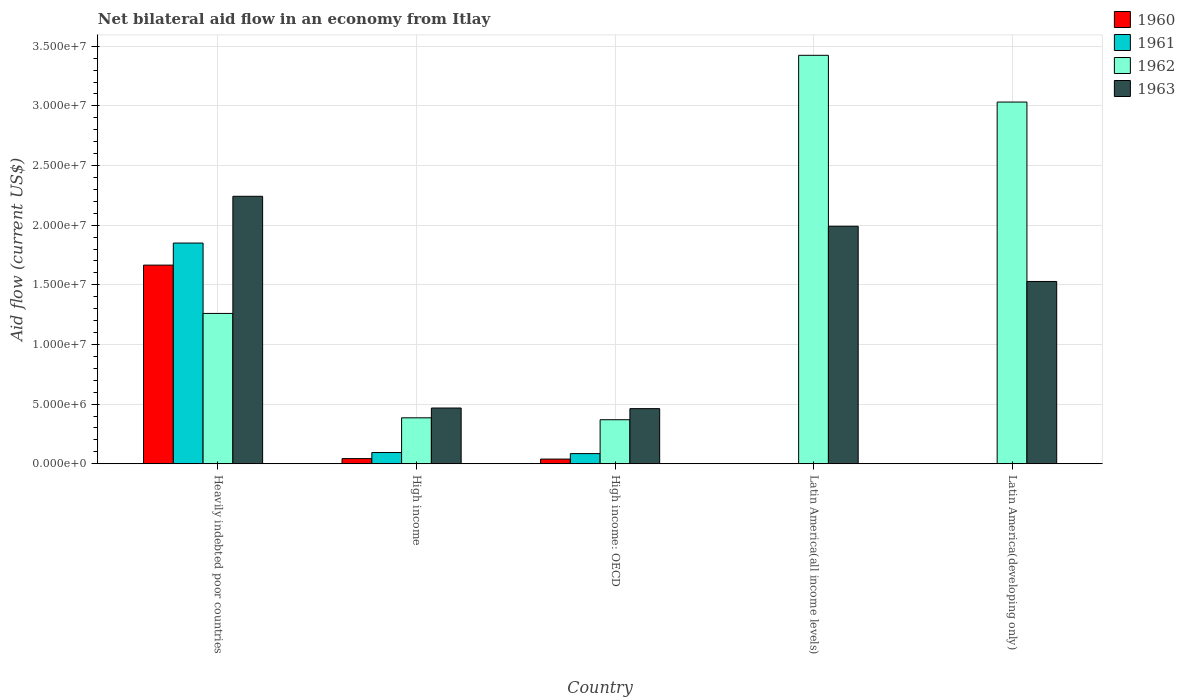How many different coloured bars are there?
Keep it short and to the point. 4. Are the number of bars per tick equal to the number of legend labels?
Provide a short and direct response. No. What is the label of the 4th group of bars from the left?
Ensure brevity in your answer.  Latin America(all income levels). In how many cases, is the number of bars for a given country not equal to the number of legend labels?
Offer a terse response. 2. What is the net bilateral aid flow in 1962 in Latin America(developing only)?
Give a very brief answer. 3.03e+07. Across all countries, what is the maximum net bilateral aid flow in 1960?
Your response must be concise. 1.66e+07. Across all countries, what is the minimum net bilateral aid flow in 1962?
Give a very brief answer. 3.69e+06. In which country was the net bilateral aid flow in 1960 maximum?
Your answer should be very brief. Heavily indebted poor countries. What is the total net bilateral aid flow in 1963 in the graph?
Provide a succinct answer. 6.69e+07. What is the difference between the net bilateral aid flow in 1962 in High income and that in Latin America(all income levels)?
Offer a very short reply. -3.04e+07. What is the difference between the net bilateral aid flow in 1962 in Heavily indebted poor countries and the net bilateral aid flow in 1963 in High income: OECD?
Your answer should be very brief. 7.98e+06. What is the average net bilateral aid flow in 1962 per country?
Your response must be concise. 1.69e+07. What is the difference between the net bilateral aid flow of/in 1962 and net bilateral aid flow of/in 1963 in Heavily indebted poor countries?
Provide a short and direct response. -9.82e+06. In how many countries, is the net bilateral aid flow in 1962 greater than 12000000 US$?
Your response must be concise. 3. What is the ratio of the net bilateral aid flow in 1963 in High income to that in Latin America(all income levels)?
Give a very brief answer. 0.23. Is the net bilateral aid flow in 1961 in High income less than that in High income: OECD?
Your answer should be compact. No. What is the difference between the highest and the second highest net bilateral aid flow in 1960?
Your answer should be compact. 1.63e+07. What is the difference between the highest and the lowest net bilateral aid flow in 1963?
Provide a short and direct response. 1.78e+07. Is it the case that in every country, the sum of the net bilateral aid flow in 1960 and net bilateral aid flow in 1961 is greater than the net bilateral aid flow in 1963?
Offer a terse response. No. How many bars are there?
Give a very brief answer. 16. Are all the bars in the graph horizontal?
Give a very brief answer. No. How many countries are there in the graph?
Ensure brevity in your answer.  5. Are the values on the major ticks of Y-axis written in scientific E-notation?
Give a very brief answer. Yes. Does the graph contain any zero values?
Provide a short and direct response. Yes. How many legend labels are there?
Give a very brief answer. 4. What is the title of the graph?
Give a very brief answer. Net bilateral aid flow in an economy from Itlay. Does "1966" appear as one of the legend labels in the graph?
Your answer should be very brief. No. What is the label or title of the X-axis?
Give a very brief answer. Country. What is the label or title of the Y-axis?
Provide a succinct answer. Aid flow (current US$). What is the Aid flow (current US$) in 1960 in Heavily indebted poor countries?
Offer a terse response. 1.66e+07. What is the Aid flow (current US$) in 1961 in Heavily indebted poor countries?
Your answer should be compact. 1.85e+07. What is the Aid flow (current US$) in 1962 in Heavily indebted poor countries?
Ensure brevity in your answer.  1.26e+07. What is the Aid flow (current US$) of 1963 in Heavily indebted poor countries?
Ensure brevity in your answer.  2.24e+07. What is the Aid flow (current US$) of 1960 in High income?
Provide a succinct answer. 4.30e+05. What is the Aid flow (current US$) of 1961 in High income?
Make the answer very short. 9.40e+05. What is the Aid flow (current US$) of 1962 in High income?
Your response must be concise. 3.85e+06. What is the Aid flow (current US$) of 1963 in High income?
Offer a terse response. 4.67e+06. What is the Aid flow (current US$) in 1961 in High income: OECD?
Provide a succinct answer. 8.50e+05. What is the Aid flow (current US$) in 1962 in High income: OECD?
Keep it short and to the point. 3.69e+06. What is the Aid flow (current US$) of 1963 in High income: OECD?
Give a very brief answer. 4.62e+06. What is the Aid flow (current US$) of 1961 in Latin America(all income levels)?
Offer a very short reply. 0. What is the Aid flow (current US$) in 1962 in Latin America(all income levels)?
Give a very brief answer. 3.42e+07. What is the Aid flow (current US$) in 1963 in Latin America(all income levels)?
Keep it short and to the point. 1.99e+07. What is the Aid flow (current US$) of 1961 in Latin America(developing only)?
Give a very brief answer. 0. What is the Aid flow (current US$) in 1962 in Latin America(developing only)?
Offer a terse response. 3.03e+07. What is the Aid flow (current US$) of 1963 in Latin America(developing only)?
Offer a very short reply. 1.53e+07. Across all countries, what is the maximum Aid flow (current US$) of 1960?
Make the answer very short. 1.66e+07. Across all countries, what is the maximum Aid flow (current US$) of 1961?
Keep it short and to the point. 1.85e+07. Across all countries, what is the maximum Aid flow (current US$) of 1962?
Your response must be concise. 3.42e+07. Across all countries, what is the maximum Aid flow (current US$) in 1963?
Your response must be concise. 2.24e+07. Across all countries, what is the minimum Aid flow (current US$) of 1960?
Give a very brief answer. 0. Across all countries, what is the minimum Aid flow (current US$) in 1961?
Your response must be concise. 0. Across all countries, what is the minimum Aid flow (current US$) in 1962?
Keep it short and to the point. 3.69e+06. Across all countries, what is the minimum Aid flow (current US$) of 1963?
Give a very brief answer. 4.62e+06. What is the total Aid flow (current US$) in 1960 in the graph?
Give a very brief answer. 1.75e+07. What is the total Aid flow (current US$) in 1961 in the graph?
Your response must be concise. 2.03e+07. What is the total Aid flow (current US$) of 1962 in the graph?
Ensure brevity in your answer.  8.47e+07. What is the total Aid flow (current US$) in 1963 in the graph?
Keep it short and to the point. 6.69e+07. What is the difference between the Aid flow (current US$) in 1960 in Heavily indebted poor countries and that in High income?
Give a very brief answer. 1.62e+07. What is the difference between the Aid flow (current US$) in 1961 in Heavily indebted poor countries and that in High income?
Give a very brief answer. 1.76e+07. What is the difference between the Aid flow (current US$) in 1962 in Heavily indebted poor countries and that in High income?
Make the answer very short. 8.75e+06. What is the difference between the Aid flow (current US$) of 1963 in Heavily indebted poor countries and that in High income?
Make the answer very short. 1.78e+07. What is the difference between the Aid flow (current US$) of 1960 in Heavily indebted poor countries and that in High income: OECD?
Keep it short and to the point. 1.63e+07. What is the difference between the Aid flow (current US$) in 1961 in Heavily indebted poor countries and that in High income: OECD?
Make the answer very short. 1.76e+07. What is the difference between the Aid flow (current US$) of 1962 in Heavily indebted poor countries and that in High income: OECD?
Provide a succinct answer. 8.91e+06. What is the difference between the Aid flow (current US$) in 1963 in Heavily indebted poor countries and that in High income: OECD?
Offer a very short reply. 1.78e+07. What is the difference between the Aid flow (current US$) of 1962 in Heavily indebted poor countries and that in Latin America(all income levels)?
Offer a very short reply. -2.16e+07. What is the difference between the Aid flow (current US$) in 1963 in Heavily indebted poor countries and that in Latin America(all income levels)?
Give a very brief answer. 2.51e+06. What is the difference between the Aid flow (current US$) of 1962 in Heavily indebted poor countries and that in Latin America(developing only)?
Ensure brevity in your answer.  -1.77e+07. What is the difference between the Aid flow (current US$) of 1963 in Heavily indebted poor countries and that in Latin America(developing only)?
Make the answer very short. 7.14e+06. What is the difference between the Aid flow (current US$) in 1962 in High income and that in Latin America(all income levels)?
Your answer should be compact. -3.04e+07. What is the difference between the Aid flow (current US$) of 1963 in High income and that in Latin America(all income levels)?
Provide a short and direct response. -1.52e+07. What is the difference between the Aid flow (current US$) of 1962 in High income and that in Latin America(developing only)?
Your answer should be very brief. -2.65e+07. What is the difference between the Aid flow (current US$) in 1963 in High income and that in Latin America(developing only)?
Provide a short and direct response. -1.06e+07. What is the difference between the Aid flow (current US$) of 1962 in High income: OECD and that in Latin America(all income levels)?
Offer a terse response. -3.06e+07. What is the difference between the Aid flow (current US$) in 1963 in High income: OECD and that in Latin America(all income levels)?
Keep it short and to the point. -1.53e+07. What is the difference between the Aid flow (current US$) of 1962 in High income: OECD and that in Latin America(developing only)?
Keep it short and to the point. -2.66e+07. What is the difference between the Aid flow (current US$) of 1963 in High income: OECD and that in Latin America(developing only)?
Ensure brevity in your answer.  -1.07e+07. What is the difference between the Aid flow (current US$) of 1962 in Latin America(all income levels) and that in Latin America(developing only)?
Make the answer very short. 3.92e+06. What is the difference between the Aid flow (current US$) of 1963 in Latin America(all income levels) and that in Latin America(developing only)?
Ensure brevity in your answer.  4.63e+06. What is the difference between the Aid flow (current US$) in 1960 in Heavily indebted poor countries and the Aid flow (current US$) in 1961 in High income?
Your answer should be compact. 1.57e+07. What is the difference between the Aid flow (current US$) of 1960 in Heavily indebted poor countries and the Aid flow (current US$) of 1962 in High income?
Provide a short and direct response. 1.28e+07. What is the difference between the Aid flow (current US$) of 1960 in Heavily indebted poor countries and the Aid flow (current US$) of 1963 in High income?
Your answer should be compact. 1.20e+07. What is the difference between the Aid flow (current US$) in 1961 in Heavily indebted poor countries and the Aid flow (current US$) in 1962 in High income?
Your answer should be very brief. 1.46e+07. What is the difference between the Aid flow (current US$) in 1961 in Heavily indebted poor countries and the Aid flow (current US$) in 1963 in High income?
Ensure brevity in your answer.  1.38e+07. What is the difference between the Aid flow (current US$) in 1962 in Heavily indebted poor countries and the Aid flow (current US$) in 1963 in High income?
Keep it short and to the point. 7.93e+06. What is the difference between the Aid flow (current US$) in 1960 in Heavily indebted poor countries and the Aid flow (current US$) in 1961 in High income: OECD?
Make the answer very short. 1.58e+07. What is the difference between the Aid flow (current US$) in 1960 in Heavily indebted poor countries and the Aid flow (current US$) in 1962 in High income: OECD?
Offer a very short reply. 1.30e+07. What is the difference between the Aid flow (current US$) of 1960 in Heavily indebted poor countries and the Aid flow (current US$) of 1963 in High income: OECD?
Your answer should be very brief. 1.20e+07. What is the difference between the Aid flow (current US$) of 1961 in Heavily indebted poor countries and the Aid flow (current US$) of 1962 in High income: OECD?
Offer a very short reply. 1.48e+07. What is the difference between the Aid flow (current US$) in 1961 in Heavily indebted poor countries and the Aid flow (current US$) in 1963 in High income: OECD?
Offer a very short reply. 1.39e+07. What is the difference between the Aid flow (current US$) in 1962 in Heavily indebted poor countries and the Aid flow (current US$) in 1963 in High income: OECD?
Offer a terse response. 7.98e+06. What is the difference between the Aid flow (current US$) in 1960 in Heavily indebted poor countries and the Aid flow (current US$) in 1962 in Latin America(all income levels)?
Ensure brevity in your answer.  -1.76e+07. What is the difference between the Aid flow (current US$) of 1960 in Heavily indebted poor countries and the Aid flow (current US$) of 1963 in Latin America(all income levels)?
Your answer should be compact. -3.26e+06. What is the difference between the Aid flow (current US$) in 1961 in Heavily indebted poor countries and the Aid flow (current US$) in 1962 in Latin America(all income levels)?
Keep it short and to the point. -1.57e+07. What is the difference between the Aid flow (current US$) of 1961 in Heavily indebted poor countries and the Aid flow (current US$) of 1963 in Latin America(all income levels)?
Provide a succinct answer. -1.41e+06. What is the difference between the Aid flow (current US$) of 1962 in Heavily indebted poor countries and the Aid flow (current US$) of 1963 in Latin America(all income levels)?
Offer a terse response. -7.31e+06. What is the difference between the Aid flow (current US$) of 1960 in Heavily indebted poor countries and the Aid flow (current US$) of 1962 in Latin America(developing only)?
Provide a short and direct response. -1.37e+07. What is the difference between the Aid flow (current US$) of 1960 in Heavily indebted poor countries and the Aid flow (current US$) of 1963 in Latin America(developing only)?
Offer a very short reply. 1.37e+06. What is the difference between the Aid flow (current US$) in 1961 in Heavily indebted poor countries and the Aid flow (current US$) in 1962 in Latin America(developing only)?
Keep it short and to the point. -1.18e+07. What is the difference between the Aid flow (current US$) in 1961 in Heavily indebted poor countries and the Aid flow (current US$) in 1963 in Latin America(developing only)?
Offer a terse response. 3.22e+06. What is the difference between the Aid flow (current US$) of 1962 in Heavily indebted poor countries and the Aid flow (current US$) of 1963 in Latin America(developing only)?
Make the answer very short. -2.68e+06. What is the difference between the Aid flow (current US$) of 1960 in High income and the Aid flow (current US$) of 1961 in High income: OECD?
Provide a succinct answer. -4.20e+05. What is the difference between the Aid flow (current US$) of 1960 in High income and the Aid flow (current US$) of 1962 in High income: OECD?
Provide a short and direct response. -3.26e+06. What is the difference between the Aid flow (current US$) in 1960 in High income and the Aid flow (current US$) in 1963 in High income: OECD?
Offer a terse response. -4.19e+06. What is the difference between the Aid flow (current US$) in 1961 in High income and the Aid flow (current US$) in 1962 in High income: OECD?
Give a very brief answer. -2.75e+06. What is the difference between the Aid flow (current US$) in 1961 in High income and the Aid flow (current US$) in 1963 in High income: OECD?
Keep it short and to the point. -3.68e+06. What is the difference between the Aid flow (current US$) in 1962 in High income and the Aid flow (current US$) in 1963 in High income: OECD?
Your answer should be compact. -7.70e+05. What is the difference between the Aid flow (current US$) of 1960 in High income and the Aid flow (current US$) of 1962 in Latin America(all income levels)?
Provide a succinct answer. -3.38e+07. What is the difference between the Aid flow (current US$) of 1960 in High income and the Aid flow (current US$) of 1963 in Latin America(all income levels)?
Your response must be concise. -1.95e+07. What is the difference between the Aid flow (current US$) in 1961 in High income and the Aid flow (current US$) in 1962 in Latin America(all income levels)?
Ensure brevity in your answer.  -3.33e+07. What is the difference between the Aid flow (current US$) of 1961 in High income and the Aid flow (current US$) of 1963 in Latin America(all income levels)?
Offer a very short reply. -1.90e+07. What is the difference between the Aid flow (current US$) in 1962 in High income and the Aid flow (current US$) in 1963 in Latin America(all income levels)?
Make the answer very short. -1.61e+07. What is the difference between the Aid flow (current US$) in 1960 in High income and the Aid flow (current US$) in 1962 in Latin America(developing only)?
Give a very brief answer. -2.99e+07. What is the difference between the Aid flow (current US$) in 1960 in High income and the Aid flow (current US$) in 1963 in Latin America(developing only)?
Your answer should be compact. -1.48e+07. What is the difference between the Aid flow (current US$) of 1961 in High income and the Aid flow (current US$) of 1962 in Latin America(developing only)?
Offer a very short reply. -2.94e+07. What is the difference between the Aid flow (current US$) of 1961 in High income and the Aid flow (current US$) of 1963 in Latin America(developing only)?
Make the answer very short. -1.43e+07. What is the difference between the Aid flow (current US$) in 1962 in High income and the Aid flow (current US$) in 1963 in Latin America(developing only)?
Keep it short and to the point. -1.14e+07. What is the difference between the Aid flow (current US$) in 1960 in High income: OECD and the Aid flow (current US$) in 1962 in Latin America(all income levels)?
Provide a succinct answer. -3.38e+07. What is the difference between the Aid flow (current US$) in 1960 in High income: OECD and the Aid flow (current US$) in 1963 in Latin America(all income levels)?
Your answer should be compact. -1.95e+07. What is the difference between the Aid flow (current US$) of 1961 in High income: OECD and the Aid flow (current US$) of 1962 in Latin America(all income levels)?
Keep it short and to the point. -3.34e+07. What is the difference between the Aid flow (current US$) of 1961 in High income: OECD and the Aid flow (current US$) of 1963 in Latin America(all income levels)?
Keep it short and to the point. -1.91e+07. What is the difference between the Aid flow (current US$) in 1962 in High income: OECD and the Aid flow (current US$) in 1963 in Latin America(all income levels)?
Your answer should be very brief. -1.62e+07. What is the difference between the Aid flow (current US$) in 1960 in High income: OECD and the Aid flow (current US$) in 1962 in Latin America(developing only)?
Your answer should be compact. -2.99e+07. What is the difference between the Aid flow (current US$) of 1960 in High income: OECD and the Aid flow (current US$) of 1963 in Latin America(developing only)?
Your response must be concise. -1.49e+07. What is the difference between the Aid flow (current US$) of 1961 in High income: OECD and the Aid flow (current US$) of 1962 in Latin America(developing only)?
Provide a short and direct response. -2.95e+07. What is the difference between the Aid flow (current US$) in 1961 in High income: OECD and the Aid flow (current US$) in 1963 in Latin America(developing only)?
Offer a terse response. -1.44e+07. What is the difference between the Aid flow (current US$) of 1962 in High income: OECD and the Aid flow (current US$) of 1963 in Latin America(developing only)?
Give a very brief answer. -1.16e+07. What is the difference between the Aid flow (current US$) in 1962 in Latin America(all income levels) and the Aid flow (current US$) in 1963 in Latin America(developing only)?
Provide a short and direct response. 1.90e+07. What is the average Aid flow (current US$) in 1960 per country?
Provide a short and direct response. 3.49e+06. What is the average Aid flow (current US$) of 1961 per country?
Give a very brief answer. 4.06e+06. What is the average Aid flow (current US$) of 1962 per country?
Provide a succinct answer. 1.69e+07. What is the average Aid flow (current US$) of 1963 per country?
Provide a succinct answer. 1.34e+07. What is the difference between the Aid flow (current US$) in 1960 and Aid flow (current US$) in 1961 in Heavily indebted poor countries?
Give a very brief answer. -1.85e+06. What is the difference between the Aid flow (current US$) of 1960 and Aid flow (current US$) of 1962 in Heavily indebted poor countries?
Offer a very short reply. 4.05e+06. What is the difference between the Aid flow (current US$) of 1960 and Aid flow (current US$) of 1963 in Heavily indebted poor countries?
Give a very brief answer. -5.77e+06. What is the difference between the Aid flow (current US$) of 1961 and Aid flow (current US$) of 1962 in Heavily indebted poor countries?
Offer a terse response. 5.90e+06. What is the difference between the Aid flow (current US$) in 1961 and Aid flow (current US$) in 1963 in Heavily indebted poor countries?
Your answer should be very brief. -3.92e+06. What is the difference between the Aid flow (current US$) in 1962 and Aid flow (current US$) in 1963 in Heavily indebted poor countries?
Give a very brief answer. -9.82e+06. What is the difference between the Aid flow (current US$) of 1960 and Aid flow (current US$) of 1961 in High income?
Provide a short and direct response. -5.10e+05. What is the difference between the Aid flow (current US$) of 1960 and Aid flow (current US$) of 1962 in High income?
Keep it short and to the point. -3.42e+06. What is the difference between the Aid flow (current US$) of 1960 and Aid flow (current US$) of 1963 in High income?
Offer a terse response. -4.24e+06. What is the difference between the Aid flow (current US$) in 1961 and Aid flow (current US$) in 1962 in High income?
Your response must be concise. -2.91e+06. What is the difference between the Aid flow (current US$) of 1961 and Aid flow (current US$) of 1963 in High income?
Provide a short and direct response. -3.73e+06. What is the difference between the Aid flow (current US$) in 1962 and Aid flow (current US$) in 1963 in High income?
Your answer should be very brief. -8.20e+05. What is the difference between the Aid flow (current US$) of 1960 and Aid flow (current US$) of 1961 in High income: OECD?
Provide a short and direct response. -4.60e+05. What is the difference between the Aid flow (current US$) of 1960 and Aid flow (current US$) of 1962 in High income: OECD?
Keep it short and to the point. -3.30e+06. What is the difference between the Aid flow (current US$) of 1960 and Aid flow (current US$) of 1963 in High income: OECD?
Give a very brief answer. -4.23e+06. What is the difference between the Aid flow (current US$) of 1961 and Aid flow (current US$) of 1962 in High income: OECD?
Offer a terse response. -2.84e+06. What is the difference between the Aid flow (current US$) in 1961 and Aid flow (current US$) in 1963 in High income: OECD?
Offer a terse response. -3.77e+06. What is the difference between the Aid flow (current US$) of 1962 and Aid flow (current US$) of 1963 in High income: OECD?
Ensure brevity in your answer.  -9.30e+05. What is the difference between the Aid flow (current US$) of 1962 and Aid flow (current US$) of 1963 in Latin America(all income levels)?
Offer a terse response. 1.43e+07. What is the difference between the Aid flow (current US$) in 1962 and Aid flow (current US$) in 1963 in Latin America(developing only)?
Provide a short and direct response. 1.50e+07. What is the ratio of the Aid flow (current US$) in 1960 in Heavily indebted poor countries to that in High income?
Make the answer very short. 38.72. What is the ratio of the Aid flow (current US$) of 1961 in Heavily indebted poor countries to that in High income?
Give a very brief answer. 19.68. What is the ratio of the Aid flow (current US$) of 1962 in Heavily indebted poor countries to that in High income?
Your response must be concise. 3.27. What is the ratio of the Aid flow (current US$) of 1963 in Heavily indebted poor countries to that in High income?
Provide a succinct answer. 4.8. What is the ratio of the Aid flow (current US$) in 1960 in Heavily indebted poor countries to that in High income: OECD?
Give a very brief answer. 42.69. What is the ratio of the Aid flow (current US$) of 1961 in Heavily indebted poor countries to that in High income: OECD?
Offer a terse response. 21.76. What is the ratio of the Aid flow (current US$) in 1962 in Heavily indebted poor countries to that in High income: OECD?
Keep it short and to the point. 3.41. What is the ratio of the Aid flow (current US$) in 1963 in Heavily indebted poor countries to that in High income: OECD?
Give a very brief answer. 4.85. What is the ratio of the Aid flow (current US$) in 1962 in Heavily indebted poor countries to that in Latin America(all income levels)?
Keep it short and to the point. 0.37. What is the ratio of the Aid flow (current US$) of 1963 in Heavily indebted poor countries to that in Latin America(all income levels)?
Ensure brevity in your answer.  1.13. What is the ratio of the Aid flow (current US$) in 1962 in Heavily indebted poor countries to that in Latin America(developing only)?
Your answer should be compact. 0.42. What is the ratio of the Aid flow (current US$) in 1963 in Heavily indebted poor countries to that in Latin America(developing only)?
Keep it short and to the point. 1.47. What is the ratio of the Aid flow (current US$) of 1960 in High income to that in High income: OECD?
Provide a short and direct response. 1.1. What is the ratio of the Aid flow (current US$) in 1961 in High income to that in High income: OECD?
Your response must be concise. 1.11. What is the ratio of the Aid flow (current US$) of 1962 in High income to that in High income: OECD?
Provide a short and direct response. 1.04. What is the ratio of the Aid flow (current US$) of 1963 in High income to that in High income: OECD?
Offer a terse response. 1.01. What is the ratio of the Aid flow (current US$) of 1962 in High income to that in Latin America(all income levels)?
Provide a succinct answer. 0.11. What is the ratio of the Aid flow (current US$) in 1963 in High income to that in Latin America(all income levels)?
Your answer should be compact. 0.23. What is the ratio of the Aid flow (current US$) of 1962 in High income to that in Latin America(developing only)?
Ensure brevity in your answer.  0.13. What is the ratio of the Aid flow (current US$) of 1963 in High income to that in Latin America(developing only)?
Your response must be concise. 0.31. What is the ratio of the Aid flow (current US$) in 1962 in High income: OECD to that in Latin America(all income levels)?
Your response must be concise. 0.11. What is the ratio of the Aid flow (current US$) in 1963 in High income: OECD to that in Latin America(all income levels)?
Your response must be concise. 0.23. What is the ratio of the Aid flow (current US$) of 1962 in High income: OECD to that in Latin America(developing only)?
Make the answer very short. 0.12. What is the ratio of the Aid flow (current US$) of 1963 in High income: OECD to that in Latin America(developing only)?
Your answer should be very brief. 0.3. What is the ratio of the Aid flow (current US$) in 1962 in Latin America(all income levels) to that in Latin America(developing only)?
Offer a terse response. 1.13. What is the ratio of the Aid flow (current US$) in 1963 in Latin America(all income levels) to that in Latin America(developing only)?
Your response must be concise. 1.3. What is the difference between the highest and the second highest Aid flow (current US$) of 1960?
Offer a very short reply. 1.62e+07. What is the difference between the highest and the second highest Aid flow (current US$) of 1961?
Your answer should be compact. 1.76e+07. What is the difference between the highest and the second highest Aid flow (current US$) in 1962?
Provide a succinct answer. 3.92e+06. What is the difference between the highest and the second highest Aid flow (current US$) in 1963?
Ensure brevity in your answer.  2.51e+06. What is the difference between the highest and the lowest Aid flow (current US$) in 1960?
Offer a terse response. 1.66e+07. What is the difference between the highest and the lowest Aid flow (current US$) of 1961?
Provide a succinct answer. 1.85e+07. What is the difference between the highest and the lowest Aid flow (current US$) in 1962?
Provide a succinct answer. 3.06e+07. What is the difference between the highest and the lowest Aid flow (current US$) in 1963?
Your answer should be very brief. 1.78e+07. 